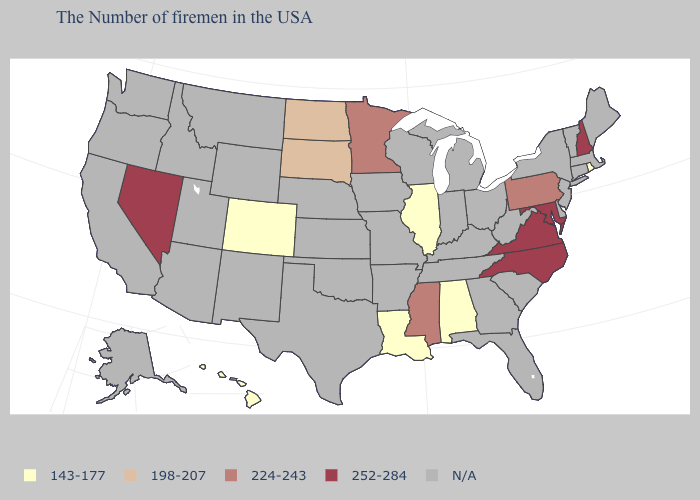Among the states that border Utah , which have the lowest value?
Answer briefly. Colorado. Name the states that have a value in the range N/A?
Concise answer only. Maine, Massachusetts, Vermont, Connecticut, New York, New Jersey, Delaware, South Carolina, West Virginia, Ohio, Florida, Georgia, Michigan, Kentucky, Indiana, Tennessee, Wisconsin, Missouri, Arkansas, Iowa, Kansas, Nebraska, Oklahoma, Texas, Wyoming, New Mexico, Utah, Montana, Arizona, Idaho, California, Washington, Oregon, Alaska. What is the value of Arizona?
Be succinct. N/A. What is the value of Missouri?
Quick response, please. N/A. Name the states that have a value in the range 143-177?
Write a very short answer. Rhode Island, Alabama, Illinois, Louisiana, Colorado, Hawaii. What is the value of Montana?
Give a very brief answer. N/A. Does the map have missing data?
Concise answer only. Yes. What is the lowest value in the Northeast?
Write a very short answer. 143-177. Name the states that have a value in the range 143-177?
Keep it brief. Rhode Island, Alabama, Illinois, Louisiana, Colorado, Hawaii. Name the states that have a value in the range N/A?
Give a very brief answer. Maine, Massachusetts, Vermont, Connecticut, New York, New Jersey, Delaware, South Carolina, West Virginia, Ohio, Florida, Georgia, Michigan, Kentucky, Indiana, Tennessee, Wisconsin, Missouri, Arkansas, Iowa, Kansas, Nebraska, Oklahoma, Texas, Wyoming, New Mexico, Utah, Montana, Arizona, Idaho, California, Washington, Oregon, Alaska. What is the lowest value in states that border South Carolina?
Answer briefly. 252-284. Among the states that border Kansas , which have the lowest value?
Answer briefly. Colorado. What is the lowest value in the USA?
Write a very short answer. 143-177. Does Louisiana have the lowest value in the South?
Short answer required. Yes. 